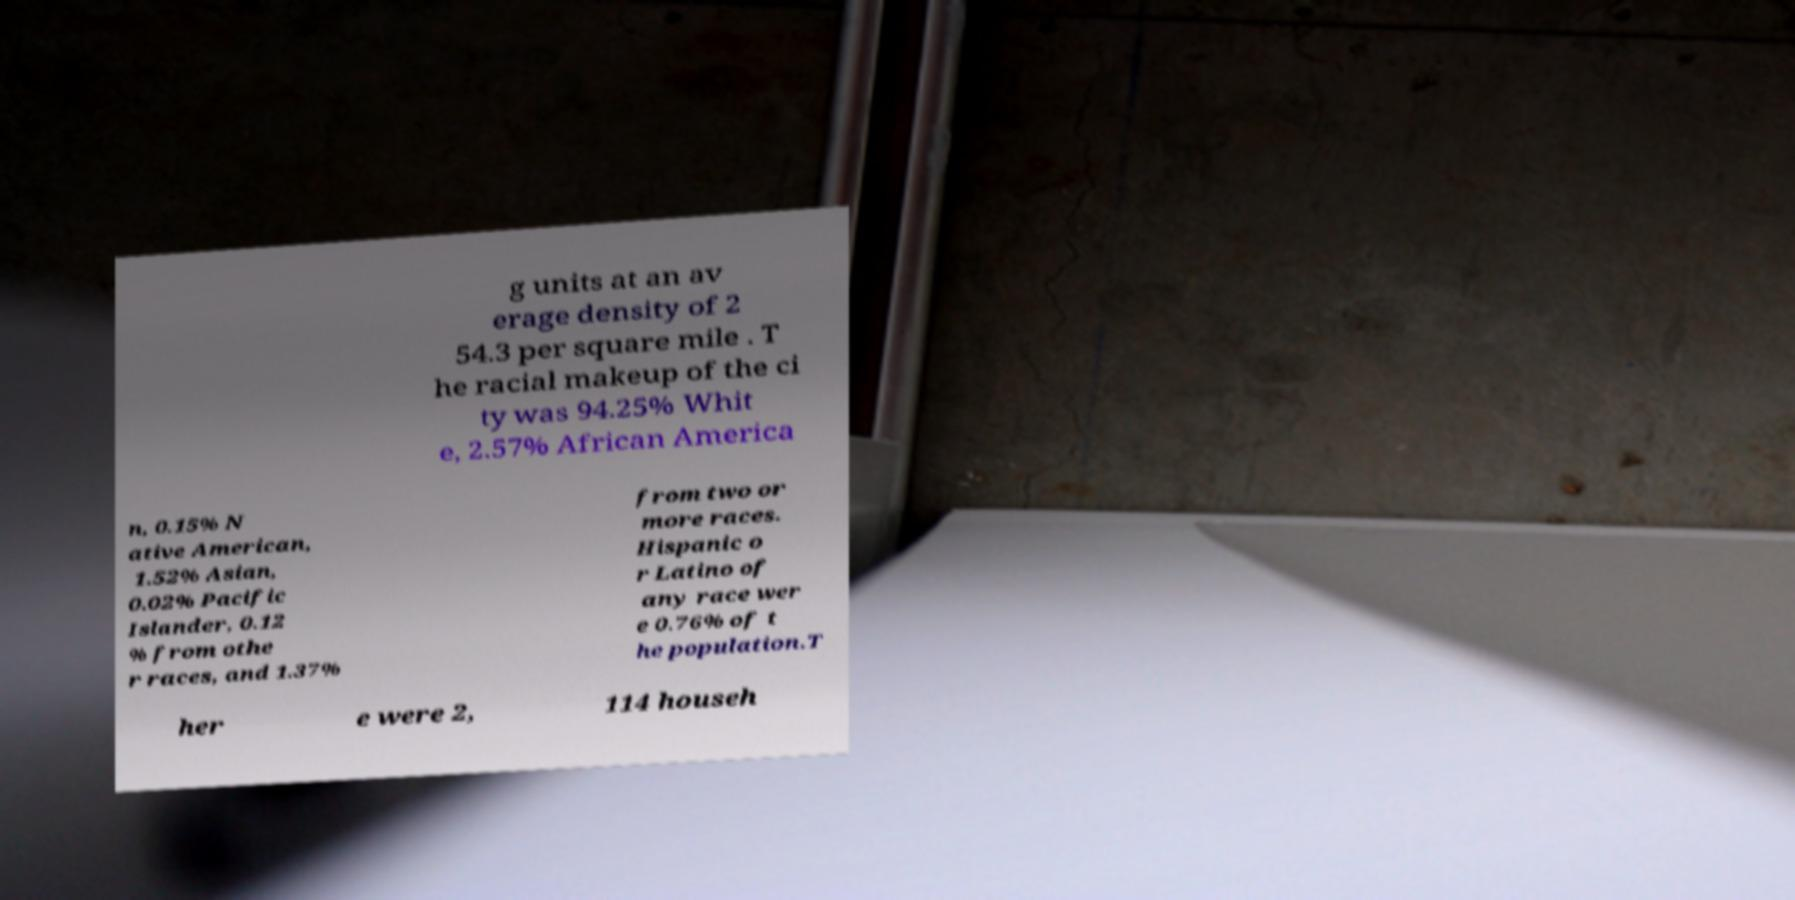For documentation purposes, I need the text within this image transcribed. Could you provide that? g units at an av erage density of 2 54.3 per square mile . T he racial makeup of the ci ty was 94.25% Whit e, 2.57% African America n, 0.15% N ative American, 1.52% Asian, 0.02% Pacific Islander, 0.12 % from othe r races, and 1.37% from two or more races. Hispanic o r Latino of any race wer e 0.76% of t he population.T her e were 2, 114 househ 